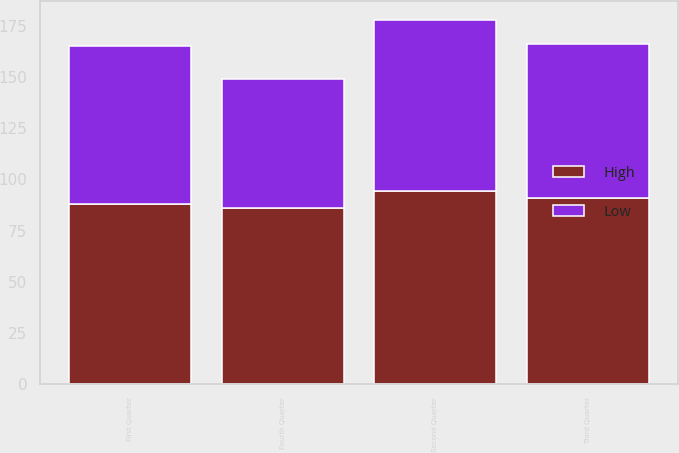Convert chart. <chart><loc_0><loc_0><loc_500><loc_500><stacked_bar_chart><ecel><fcel>First Quarter<fcel>Second Quarter<fcel>Third Quarter<fcel>Fourth Quarter<nl><fcel>High<fcel>88.18<fcel>94.38<fcel>91<fcel>85.91<nl><fcel>Low<fcel>76.9<fcel>83.67<fcel>75.14<fcel>63<nl></chart> 